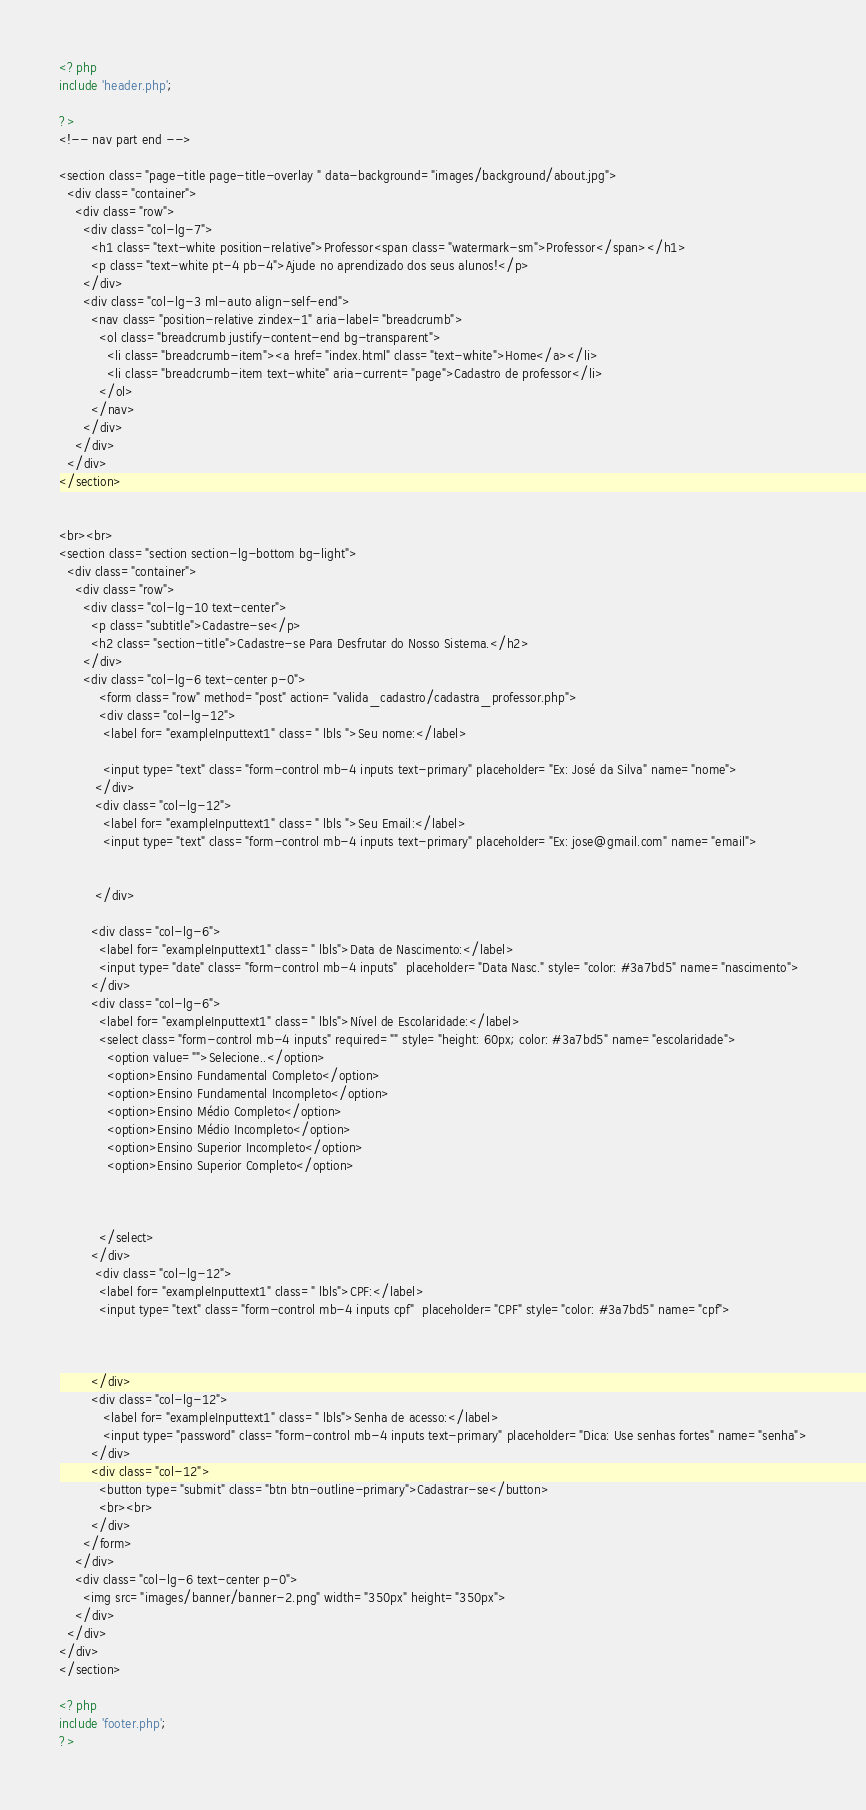Convert code to text. <code><loc_0><loc_0><loc_500><loc_500><_PHP_><?php 
include 'header.php';

?>
<!-- nav part end -->

<section class="page-title page-title-overlay " data-background="images/background/about.jpg">
  <div class="container">
    <div class="row">
      <div class="col-lg-7">
        <h1 class="text-white position-relative">Professor<span class="watermark-sm">Professor</span></h1>
        <p class="text-white pt-4 pb-4">Ajude no aprendizado dos seus alunos!</p>
      </div>
      <div class="col-lg-3 ml-auto align-self-end">
        <nav class="position-relative zindex-1" aria-label="breadcrumb">
          <ol class="breadcrumb justify-content-end bg-transparent">
            <li class="breadcrumb-item"><a href="index.html" class="text-white">Home</a></li>
            <li class="breadcrumb-item text-white" aria-current="page">Cadastro de professor</li>
          </ol>
        </nav>
      </div>
    </div>
  </div>
</section>


<br><br>
<section class="section section-lg-bottom bg-light">
  <div class="container">
    <div class="row">
      <div class="col-lg-10 text-center">
        <p class="subtitle">Cadastre-se</p>
        <h2 class="section-title">Cadastre-se Para Desfrutar do Nosso Sistema.</h2>
      </div>
      <div class="col-lg-6 text-center p-0">
          <form class="row" method="post" action="valida_cadastro/cadastra_professor.php">
          <div class="col-lg-12">
           <label for="exampleInputtext1" class=" lbls ">Seu nome:</label>

           <input type="text" class="form-control mb-4 inputs text-primary" placeholder="Ex: José da Silva" name="nome">
         </div>
         <div class="col-lg-12">
           <label for="exampleInputtext1" class=" lbls ">Seu Email:</label>
           <input type="text" class="form-control mb-4 inputs text-primary" placeholder="Ex: jose@gmail.com" name="email">

           
         </div>
         
        <div class="col-lg-6">
          <label for="exampleInputtext1" class=" lbls">Data de Nascimento:</label>
          <input type="date" class="form-control mb-4 inputs"  placeholder="Data Nasc." style="color: #3a7bd5" name="nascimento">
        </div>
        <div class="col-lg-6">
          <label for="exampleInputtext1" class=" lbls">Nível de Escolaridade:</label>
          <select class="form-control mb-4 inputs" required="" style="height: 60px; color: #3a7bd5" name="escolaridade">
            <option value="">Selecione..</option>
            <option>Ensino Fundamental Completo</option>
            <option>Ensino Fundamental Incompleto</option>
            <option>Ensino Médio Completo</option>
            <option>Ensino Médio Incompleto</option>
            <option>Ensino Superior Incompleto</option>
            <option>Ensino Superior Completo</option>



          </select>
        </div>
         <div class="col-lg-12">
          <label for="exampleInputtext1" class=" lbls">CPF:</label>
          <input type="text" class="form-control mb-4 inputs cpf"  placeholder="CPF" style="color: #3a7bd5" name="cpf">

          

        </div>
        <div class="col-lg-12">
           <label for="exampleInputtext1" class=" lbls">Senha de acesso:</label>
           <input type="password" class="form-control mb-4 inputs text-primary" placeholder="Dica: Use senhas fortes" name="senha">
        </div>
        <div class="col-12">
          <button type="submit" class="btn btn-outline-primary">Cadastrar-se</button>
          <br><br>
        </div>
      </form>
    </div>
    <div class="col-lg-6 text-center p-0">
      <img src="images/banner/banner-2.png" width="350px" height="350px">
    </div>
  </div>
</div>
</section>

<?php 
include 'footer.php';
?>
</code> 